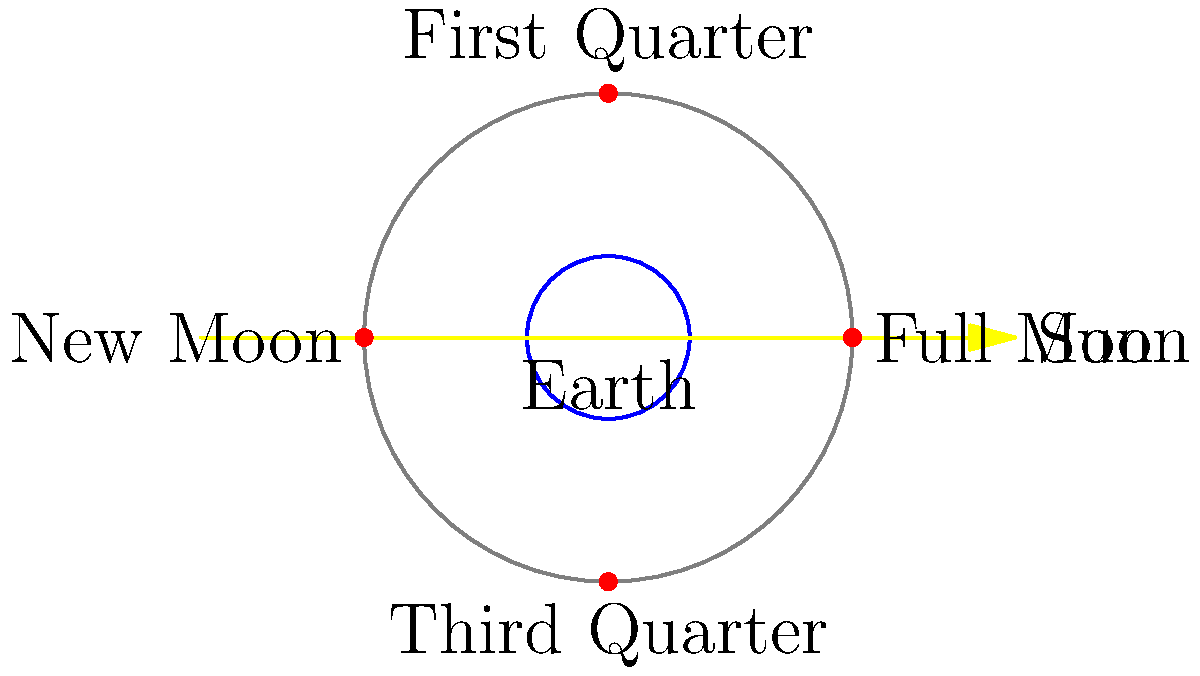As a cybersecurity analyst, you understand the importance of cyclical processes in both technology and nature. Consider the Moon's phases as a cyclical process similar to certificate lifecycle management. In the diagram, which phase of the Moon would be visible from Earth when the Moon is positioned at (0,3) in the coordinate system, and why is this phase significant in the lunar cycle? To answer this question, let's break it down step-by-step:

1. The diagram shows the Earth at the center (0,0) and the Moon's orbit around it.

2. The Sun's direction is indicated by the yellow arrow pointing from left to right.

3. The Moon's position at (0,3) is labeled as "First Quarter" in the diagram.

4. At this position, the Moon is at a 90-degree angle relative to the Earth-Sun line.

5. When the Moon is at this 90-degree angle:
   a) Half of the Moon's illuminated surface is visible from Earth.
   b) The right half of the Moon appears lit from our perspective on Earth.

6. This phase is called the First Quarter because:
   a) It marks the completion of the first quarter of the Moon's orbital cycle.
   b) It occurs about 7 days after the New Moon.

7. Significance in the lunar cycle:
   a) It represents a transition point between the waxing crescent and waxing gibbous phases.
   b) It's one of the four principal lunar phases (New Moon, First Quarter, Full Moon, Third Quarter).
   c) This phase is useful for determining cardinal directions, as the lit portion points roughly to the south in the northern hemisphere.

8. In the context of certificate lifecycle management, this phase could be analogous to the mid-point of a certificate's validity period, reminding us to prepare for renewal processes.
Answer: First Quarter Moon 